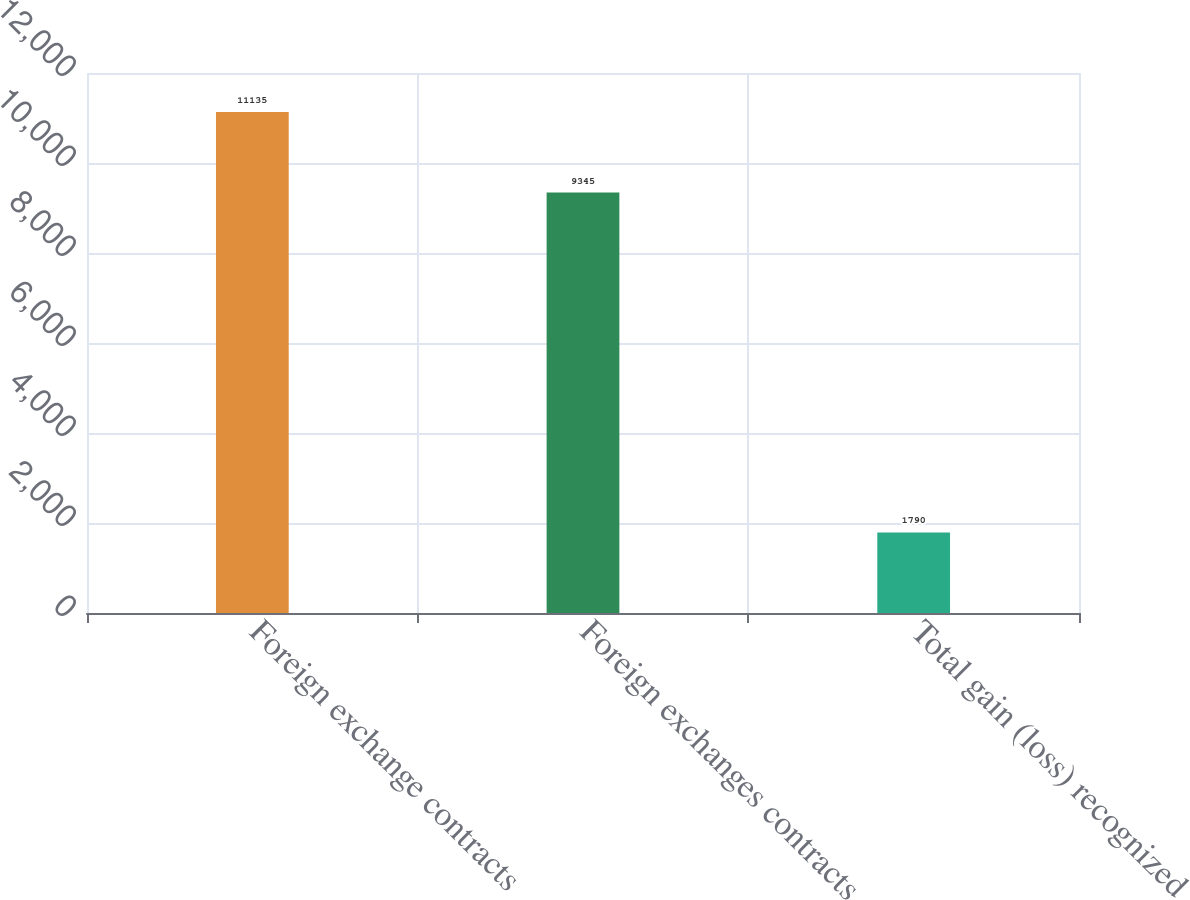Convert chart to OTSL. <chart><loc_0><loc_0><loc_500><loc_500><bar_chart><fcel>Foreign exchange contracts<fcel>Foreign exchanges contracts<fcel>Total gain (loss) recognized<nl><fcel>11135<fcel>9345<fcel>1790<nl></chart> 